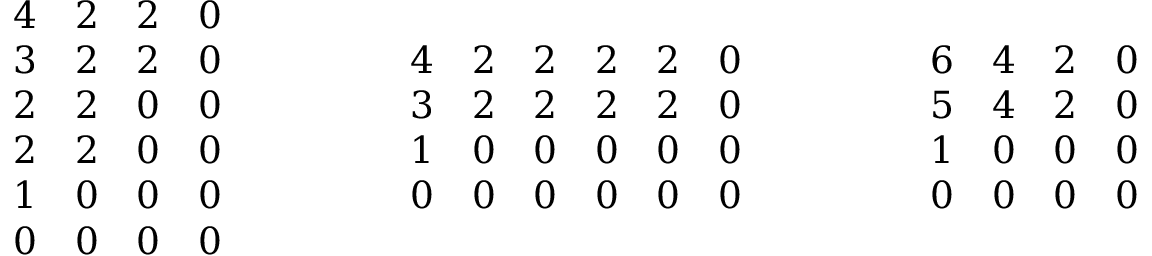<formula> <loc_0><loc_0><loc_500><loc_500>\begin{array} { r } { \begin{array} { c c c c } { 4 } & { 2 } & { 2 } & { 0 } \\ { 3 } & { 2 } & { 2 } & { 0 } \\ { 2 } & { 2 } & { 0 } & { 0 } \\ { 2 } & { 2 } & { 0 } & { 0 } \\ { 1 } & { 0 } & { 0 } & { 0 } \\ { 0 } & { 0 } & { 0 } & { 0 } \end{array} \quad \begin{array} { c c c c c c } { 4 } & { 2 } & { 2 } & { 2 } & { 2 } & { 0 } \\ { 3 } & { 2 } & { 2 } & { 2 } & { 2 } & { 0 } \\ { 1 } & { 0 } & { 0 } & { 0 } & { 0 } & { 0 } \\ { 0 } & { 0 } & { 0 } & { 0 } & { 0 } & { 0 } \end{array} \quad \begin{array} { c c c c } { 6 } & { 4 } & { 2 } & { 0 } \\ { 5 } & { 4 } & { 2 } & { 0 } \\ { 1 } & { 0 } & { 0 } & { 0 } \\ { 0 } & { 0 } & { 0 } & { 0 } \end{array} } \end{array}</formula> 